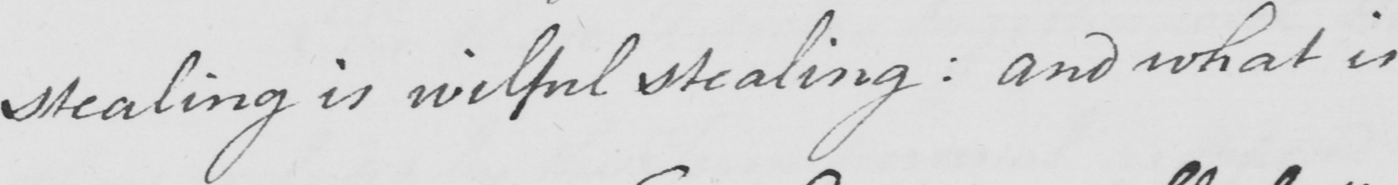Can you read and transcribe this handwriting? stealing is wilful stealing :  and what is 